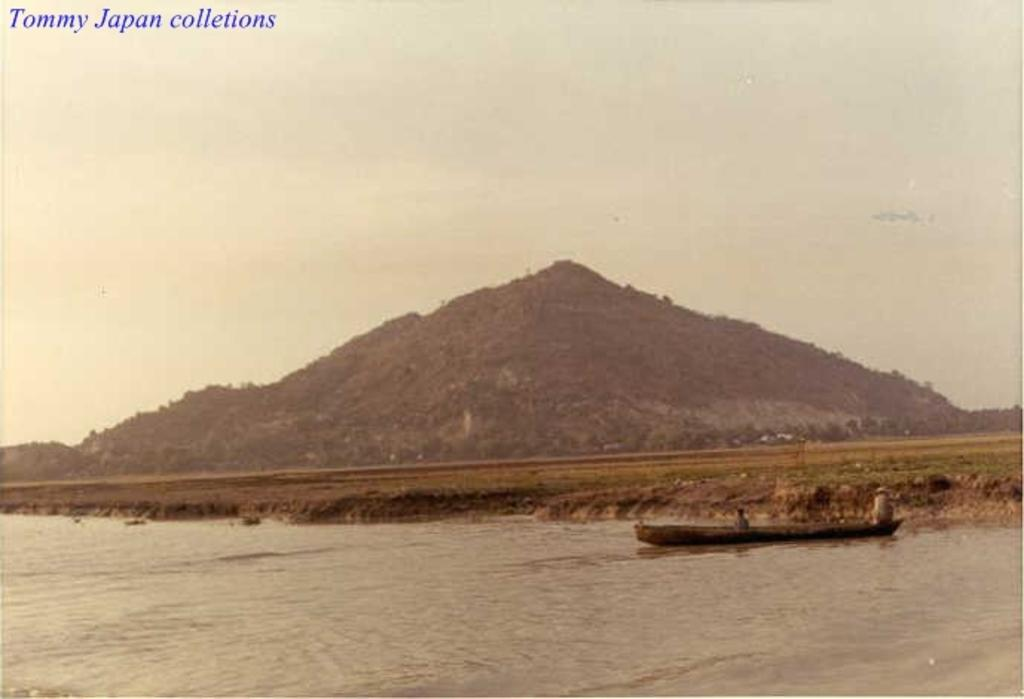What is the main subject of the image? The main subject of the image is water. What is present in the water? There is a boat in the water. What can be seen in the background of the image? There is open land visible in the background of the image, and the sky is clear. How many toes are visible on the chickens in the image? There are no chickens present in the image, so no toes can be seen. 